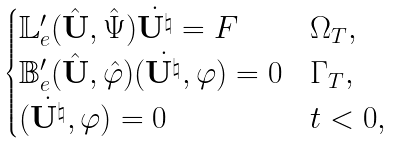<formula> <loc_0><loc_0><loc_500><loc_500>\begin{cases} \mathbb { L } ^ { \prime } _ { e } ( \hat { \mathbf U } , \hat { \Psi } ) \dot { { \mathbf U } ^ { \natural } } = F & \Omega _ { T } , \\ \mathbb { B } ^ { \prime } _ { e } ( \hat { \mathbf U } , \hat { \varphi } ) ( \dot { { \mathbf U } ^ { \natural } } , \varphi ) = 0 & \Gamma _ { T } , \\ ( \dot { { \mathbf U } ^ { \natural } } , \varphi ) = 0 & t < 0 , \end{cases}</formula> 